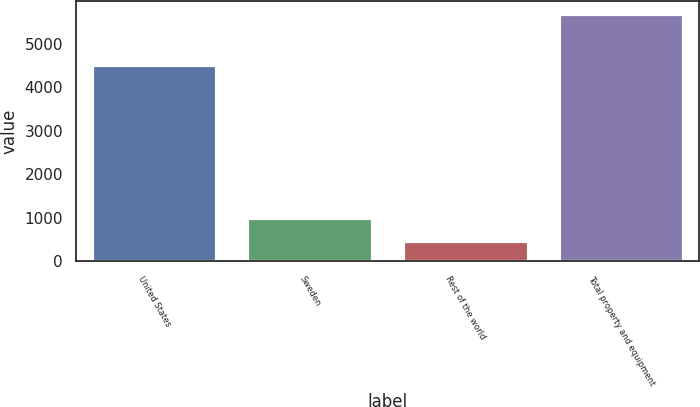Convert chart. <chart><loc_0><loc_0><loc_500><loc_500><bar_chart><fcel>United States<fcel>Sweden<fcel>Rest of the world<fcel>Total property and equipment<nl><fcel>4498<fcel>997.1<fcel>476<fcel>5687<nl></chart> 